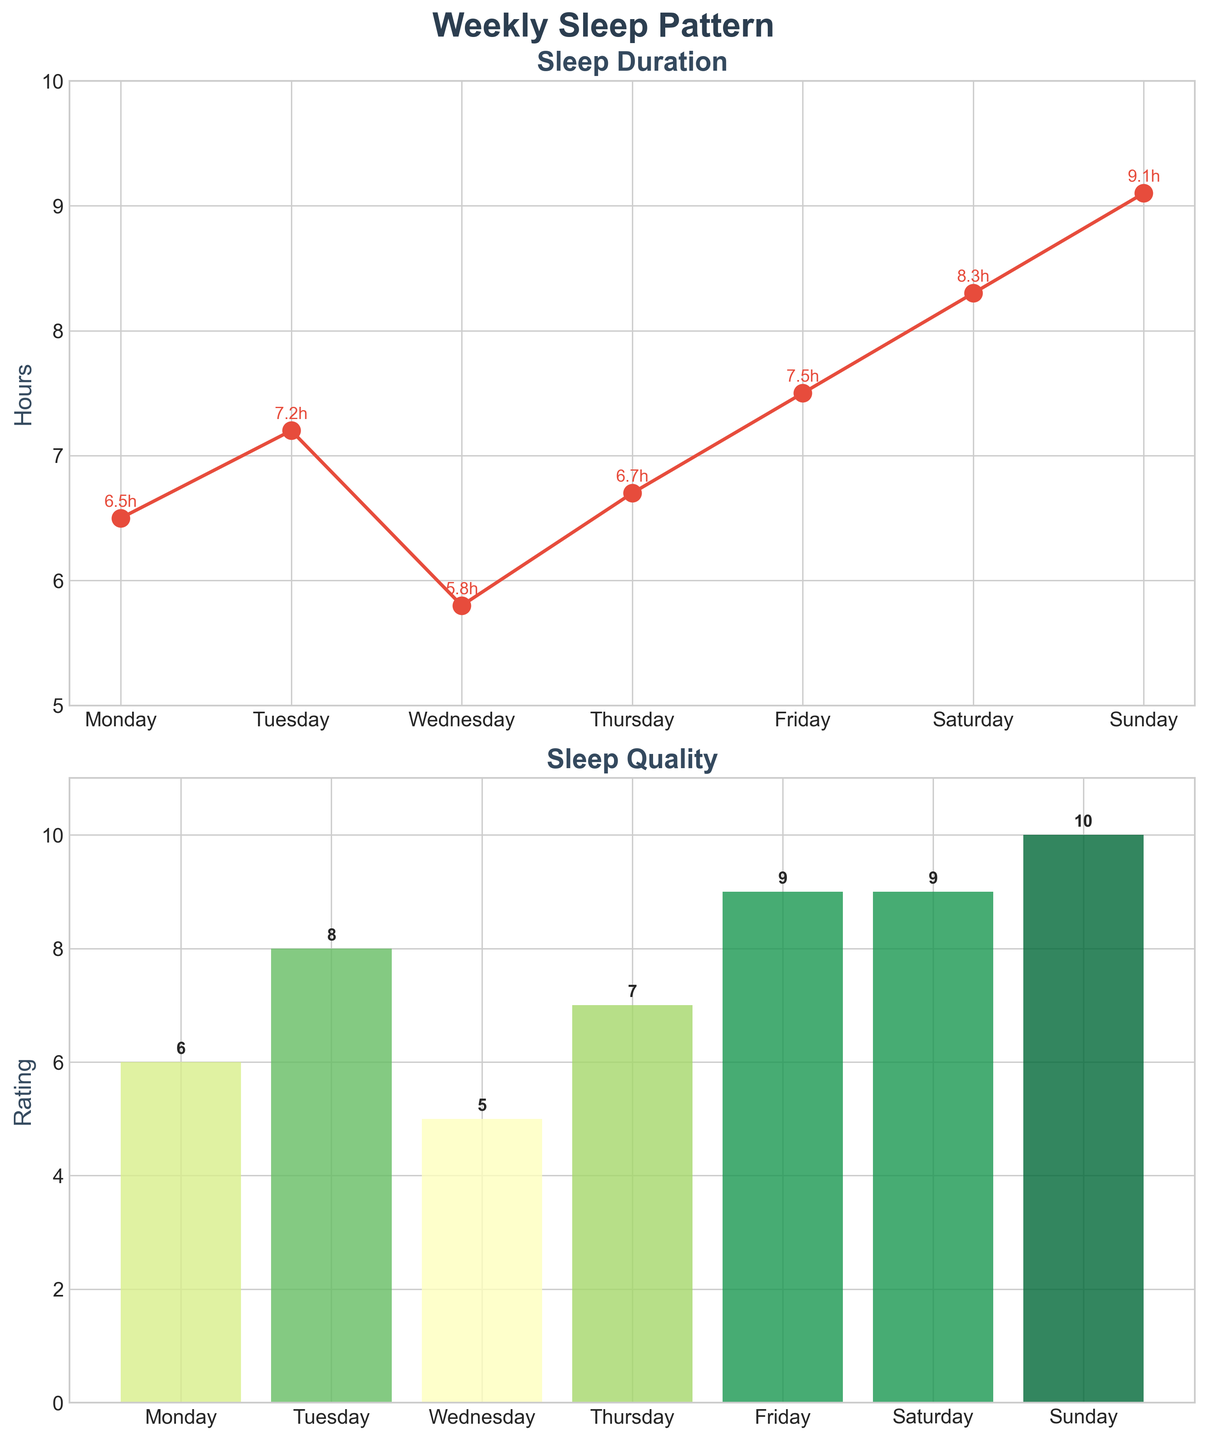What's the title of the plot? The title of the plot is located at the top of the figure, which reads "Weekly Sleep Pattern".
Answer: Weekly Sleep Pattern How many hours of sleep did I get on Wednesday? Look at the Sleep Duration plot and find the day labeled "Wednesday". The marker corresponding to Wednesday shows the duration as 5.8 hours.
Answer: 5.8 hours What is the average sleep duration over the week? The average sleep duration is calculated by summing the sleep durations for each day (6.5 + 7.2 + 5.8 + 6.7 + 7.5 + 8.3 + 9.1) and then dividing by the number of days (7). This gives (51.1 / 7) = 7.3 hours.
Answer: 7.3 hours On which day was the sleep quality the highest? Refer to the Sleep Quality bar plot. The tallest bar corresponds to Sunday, with a quality rating of 10.
Answer: Sunday Is there a trend between sleep duration and sleep quality? Analyzing the plots, generally, days with longer sleep duration tend to have higher sleep quality. For instance, the highest duration (9.1 hours on Sunday) coincides with the highest quality rating (10).
Answer: Yes What is the total sleep duration over the entire week? Calculate the total sleep duration by summing the sleep durations for each day: (6.5 + 7.2 + 5.8 + 6.7 + 7.5 + 8.3 + 9.1) = 51.1 hours.
Answer: 51.1 hours Which day had the lowest sleep quality and what was the rating? Refer to the Sleep Quality bar chart, where the shortest bar corresponds to Wednesday, with a quality rating of 5.
Answer: Wednesday, 5 What is the difference in sleep duration between Sunday and Wednesday? Find the sleep duration for Sunday (9.1 hours) and Wednesday (5.8 hours). The difference is 9.1 - 5.8 = 3.3 hours.
Answer: 3.3 hours How does the sleep quality on Monday compare to Saturday? Look at the Sleep Quality bar plot where Monday has a rating of 6 and Saturday has a rating of 9. Saturday's sleep quality is higher than Monday's.
Answer: Saturday's quality is higher What range of hours does the sleep duration span over the week? The minimum sleep duration is 5.8 hours (Wednesday) and the maximum is 9.1 hours (Sunday). The range is from 5.8 to 9.1 hours.
Answer: 5.8 to 9.1 hours 